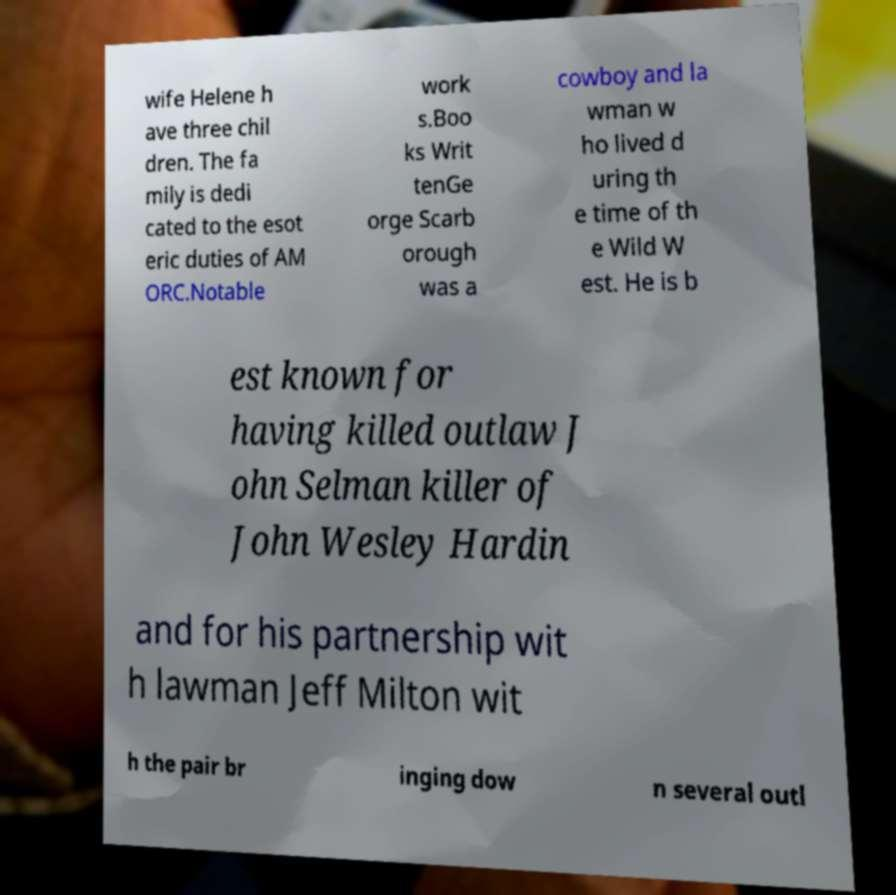I need the written content from this picture converted into text. Can you do that? wife Helene h ave three chil dren. The fa mily is dedi cated to the esot eric duties of AM ORC.Notable work s.Boo ks Writ tenGe orge Scarb orough was a cowboy and la wman w ho lived d uring th e time of th e Wild W est. He is b est known for having killed outlaw J ohn Selman killer of John Wesley Hardin and for his partnership wit h lawman Jeff Milton wit h the pair br inging dow n several outl 